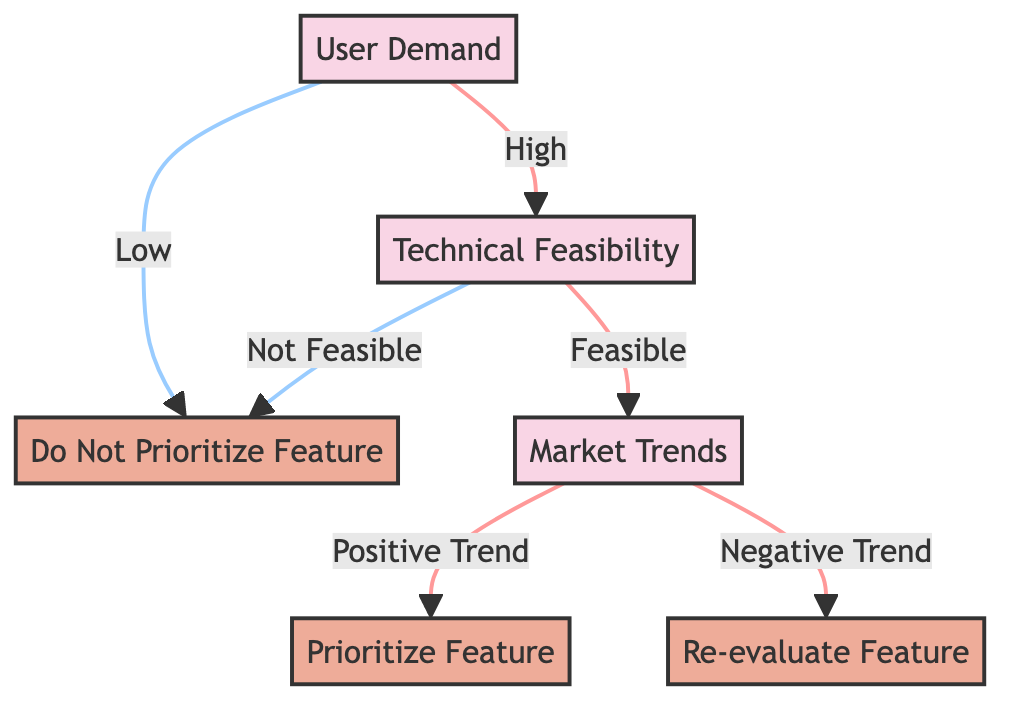What are the branches under User Demand? The branches under User Demand are High and Low. They detail the initial decision based on the level of user demand for the location-based service feature.
Answer: High, Low How many total outcomes are there in the diagram? The outcomes in the diagram are "Prioritize Feature," "Re-evaluate Feature," and "Do Not Prioritize Feature." Therefore, there are three distinct outcomes.
Answer: Three What follows if Technical Feasibility is deemed Not Feasible? If Technical Feasibility is deemed Not Feasible, the next step is to "Do Not Prioritize Feature," indicating that the feature will not be chosen for development.
Answer: Do Not Prioritize Feature What decision follows after a High User Demand and Feasible Technical Feasibility? Following a High User Demand and Feasible Technical Feasibility, the next decision is on Market Trends, determining whether to prioritize the feature based on market conditions.
Answer: Market Trends Which decision node leads to the action "Re-evaluate Feature"? The decision node that leads to the action "Re-evaluate Feature" is "Market Trends" when the trend is negative; this indicates a need to reassess the feature despite high user demand and technical feasibility.
Answer: Market Trends What happens if Market Trends show a Positive Trend? If Market Trends show a Positive Trend, the action taken is to "Prioritize Feature," meaning that the feature is selected for development based on favorable market conditions.
Answer: Prioritize Feature What is the result if User Demand is Low? If User Demand is Low, the resulting action is to "Do Not Prioritize Feature," indicating that the demand does not justify pursuing the feature.
Answer: Do Not Prioritize Feature What is the second step in the decision process? The second step in the decision process is "Technical Feasibility," as it evaluates whether the feature can be implemented given technical constraints.
Answer: Technical Feasibility If Market Trends are negative, and the User Demand is High, what should be done? If Market Trends are negative and User Demand is High, the action is to "Re-evaluate Feature," suggesting that while there is demand, market conditions may not support launching the feature currently.
Answer: Re-evaluate Feature 